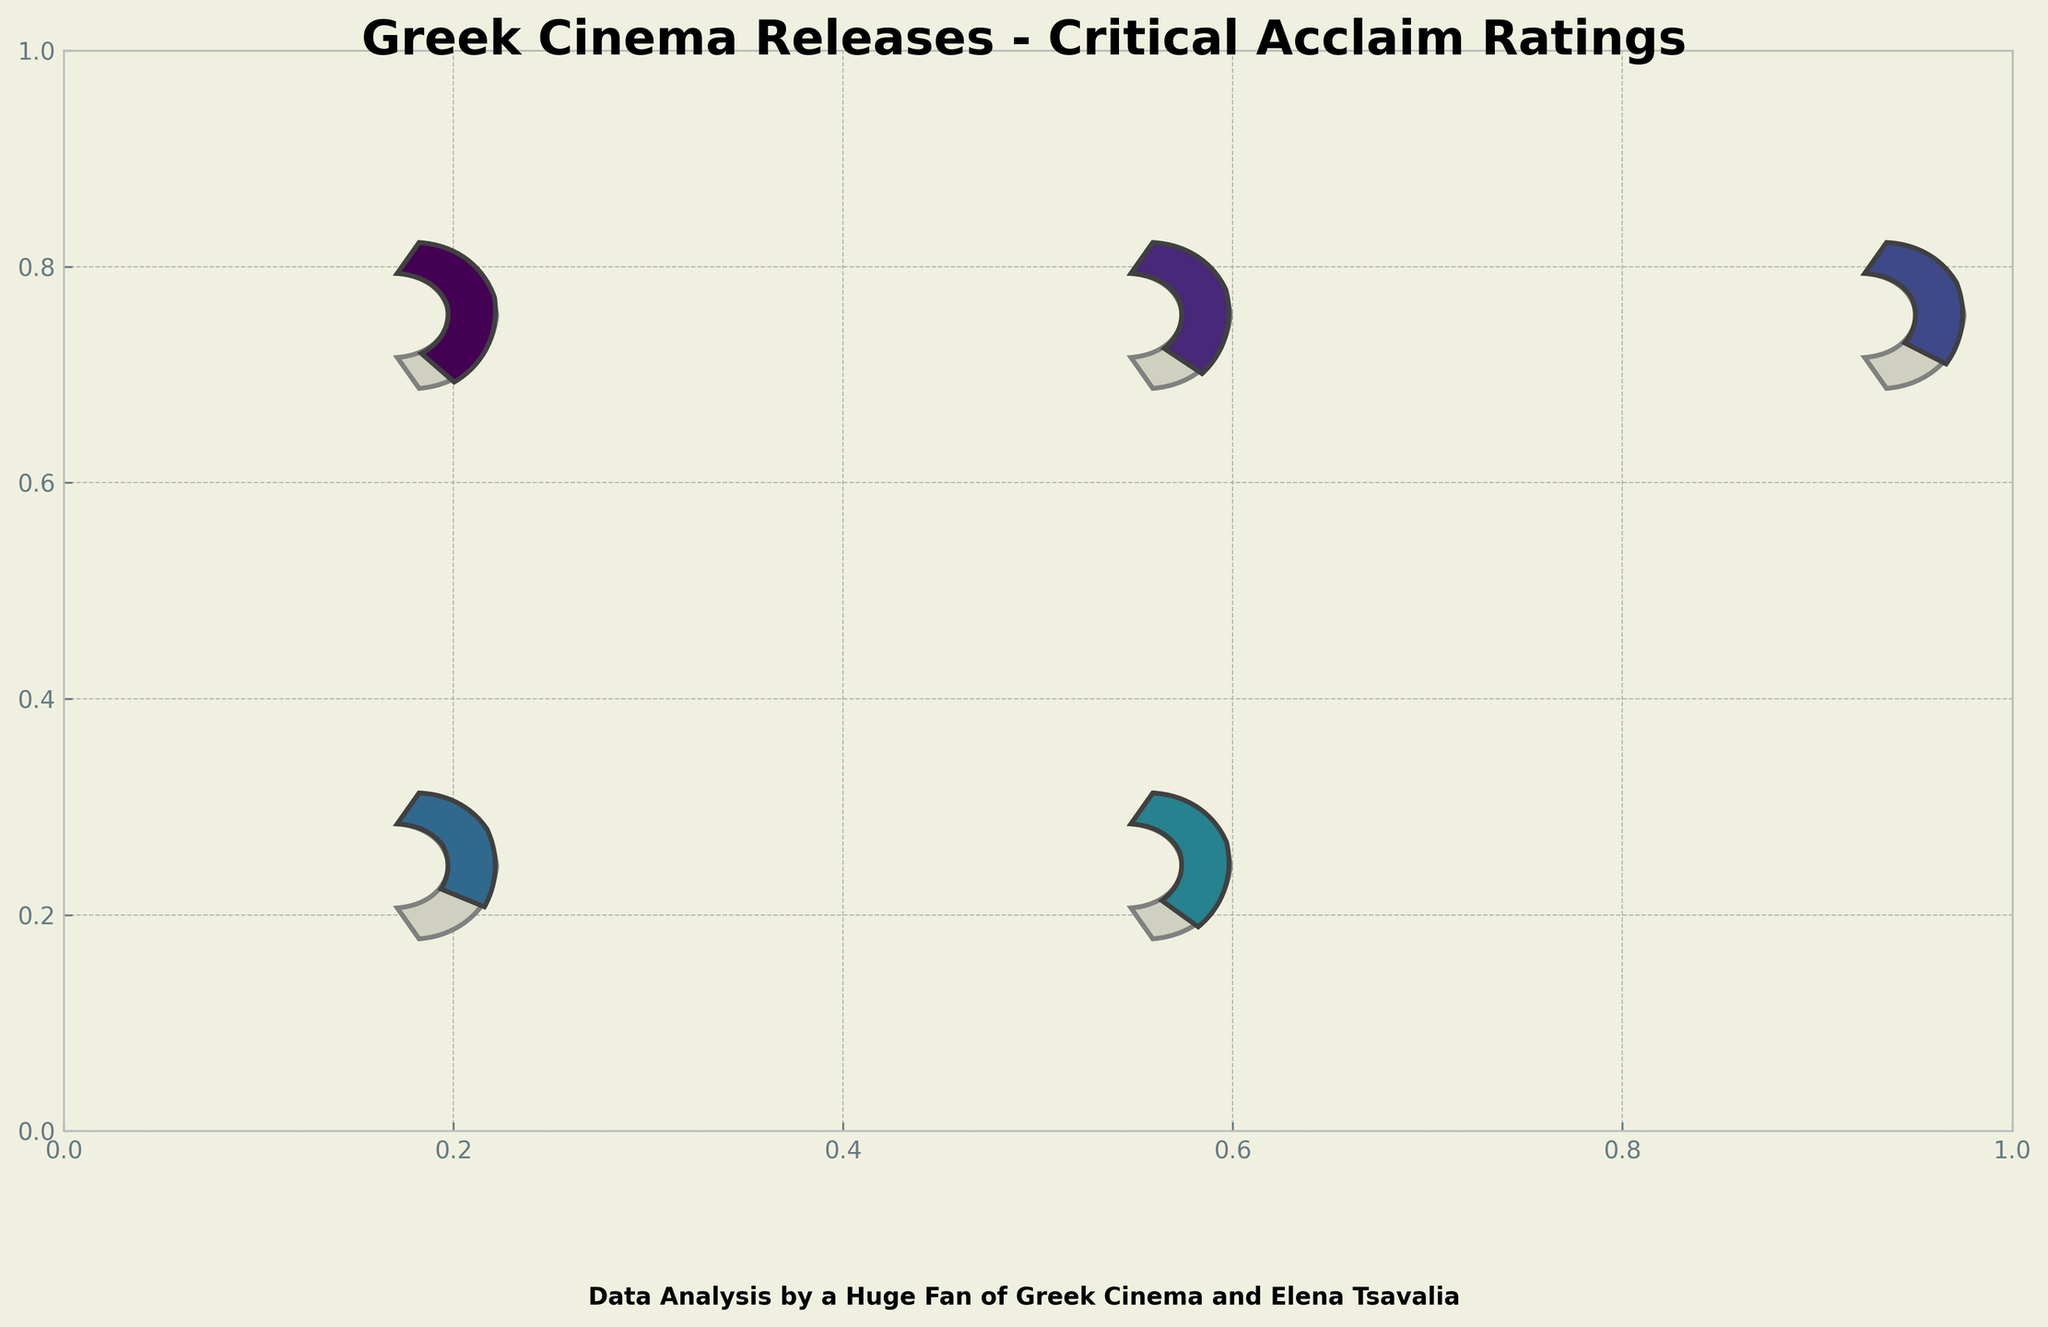What is the title of the figure? The title is usually at the top of the plot. By looking at the top, we can see the title "Greek Cinema Releases - Critical Acclaim Ratings".
Answer: Greek Cinema Releases - Critical Acclaim Ratings How many movies have a rating above 75%? Looking at each gauge chart in the figure, we can identify that "Apples" (85%), "Digger" (78%), "The Trip to Greece" (80%), and "Suntan" (76%) all have ratings above 75%. That makes it a total of four movies.
Answer: 4 Which movie has the highest critical acclaim rating? By examining the gauge charts, we find that "Apples" by Christos Nikou has the maximum rating, which is 85%.
Answer: Apples by Christos Nikou What is the average rating of the movies shown in the figure? To find the average rating, add all the ratings and divide by the number of movies. Sum of the ratings is 85 + 78 + 72 + 68 + 80 + 76 + 70 + 74 + 71 + 69 = 743. Dividing by 10 gives an average of 74.3.
Answer: 74.3 Which two movies have the closest critical acclaim ratings and what are their ratings? By comparing the ratings closely, "The Waiter" (69%) and "Defunct" (68%) have the closest ratings, with a difference of only 1%.
Answer: Defunct and The Waiter, 68% and 69% How does "Suntan" compare to "Pause" in terms of ratings? "Suntan" has a rating of 76%, and "Pause" has a rating of 74%. So, "Suntan" has a higher rating by 2%.
Answer: Suntan is higher by 2% Which movie received a rating of 80%? By examining each gauge plot for their ratings, we identify that "The Trip to Greece" has a rating of 80%.
Answer: The Trip to Greece What is the total number of movies rated between 70% and 80% (inclusive)? Checking the ratings within that range, we find "Digger" (78%), "The Miracle of the Sargasso Sea" (72%), "Suntan" (76%), "Smuggling Hendrix" (70%), "Pause" (74%), and "Her Job" (71%). This makes six movies in total.
Answer: 6 